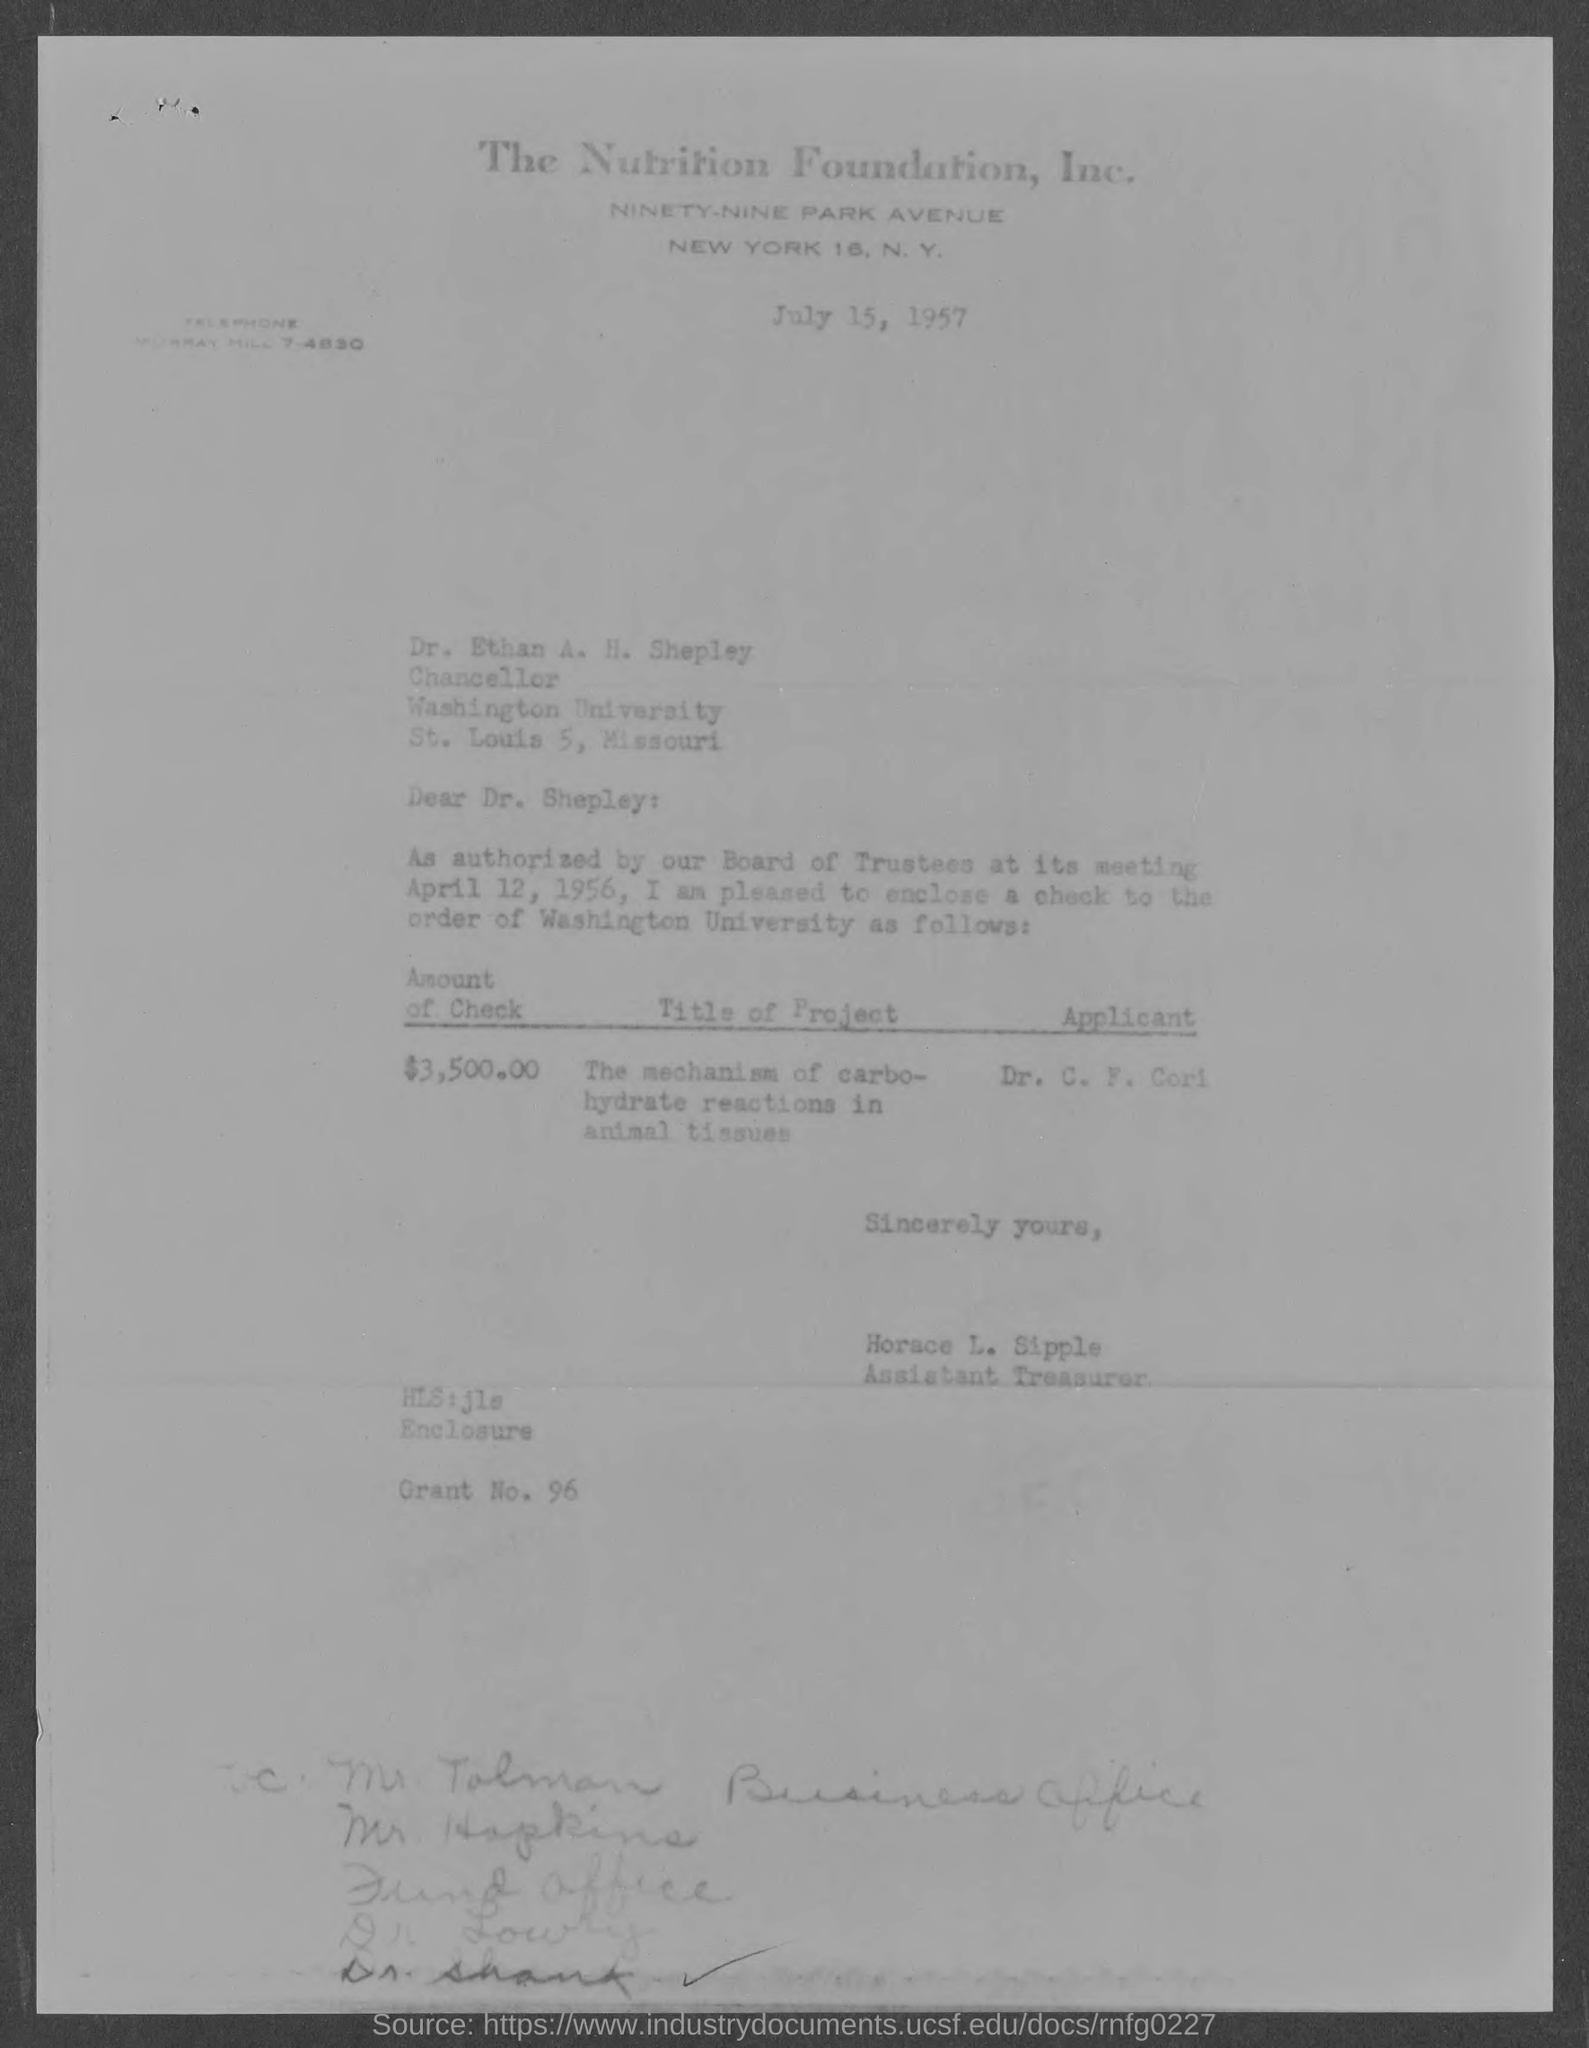What is the amount of check given in the letter ?
Provide a succinct answer. $3,500.00. What is the title of the project mentioned in the given letter ?
Give a very brief answer. The mechanism of carbohydrate reactions in animal tissues. What is the grant no. mentioned in the given letter ?
Provide a short and direct response. 96. 